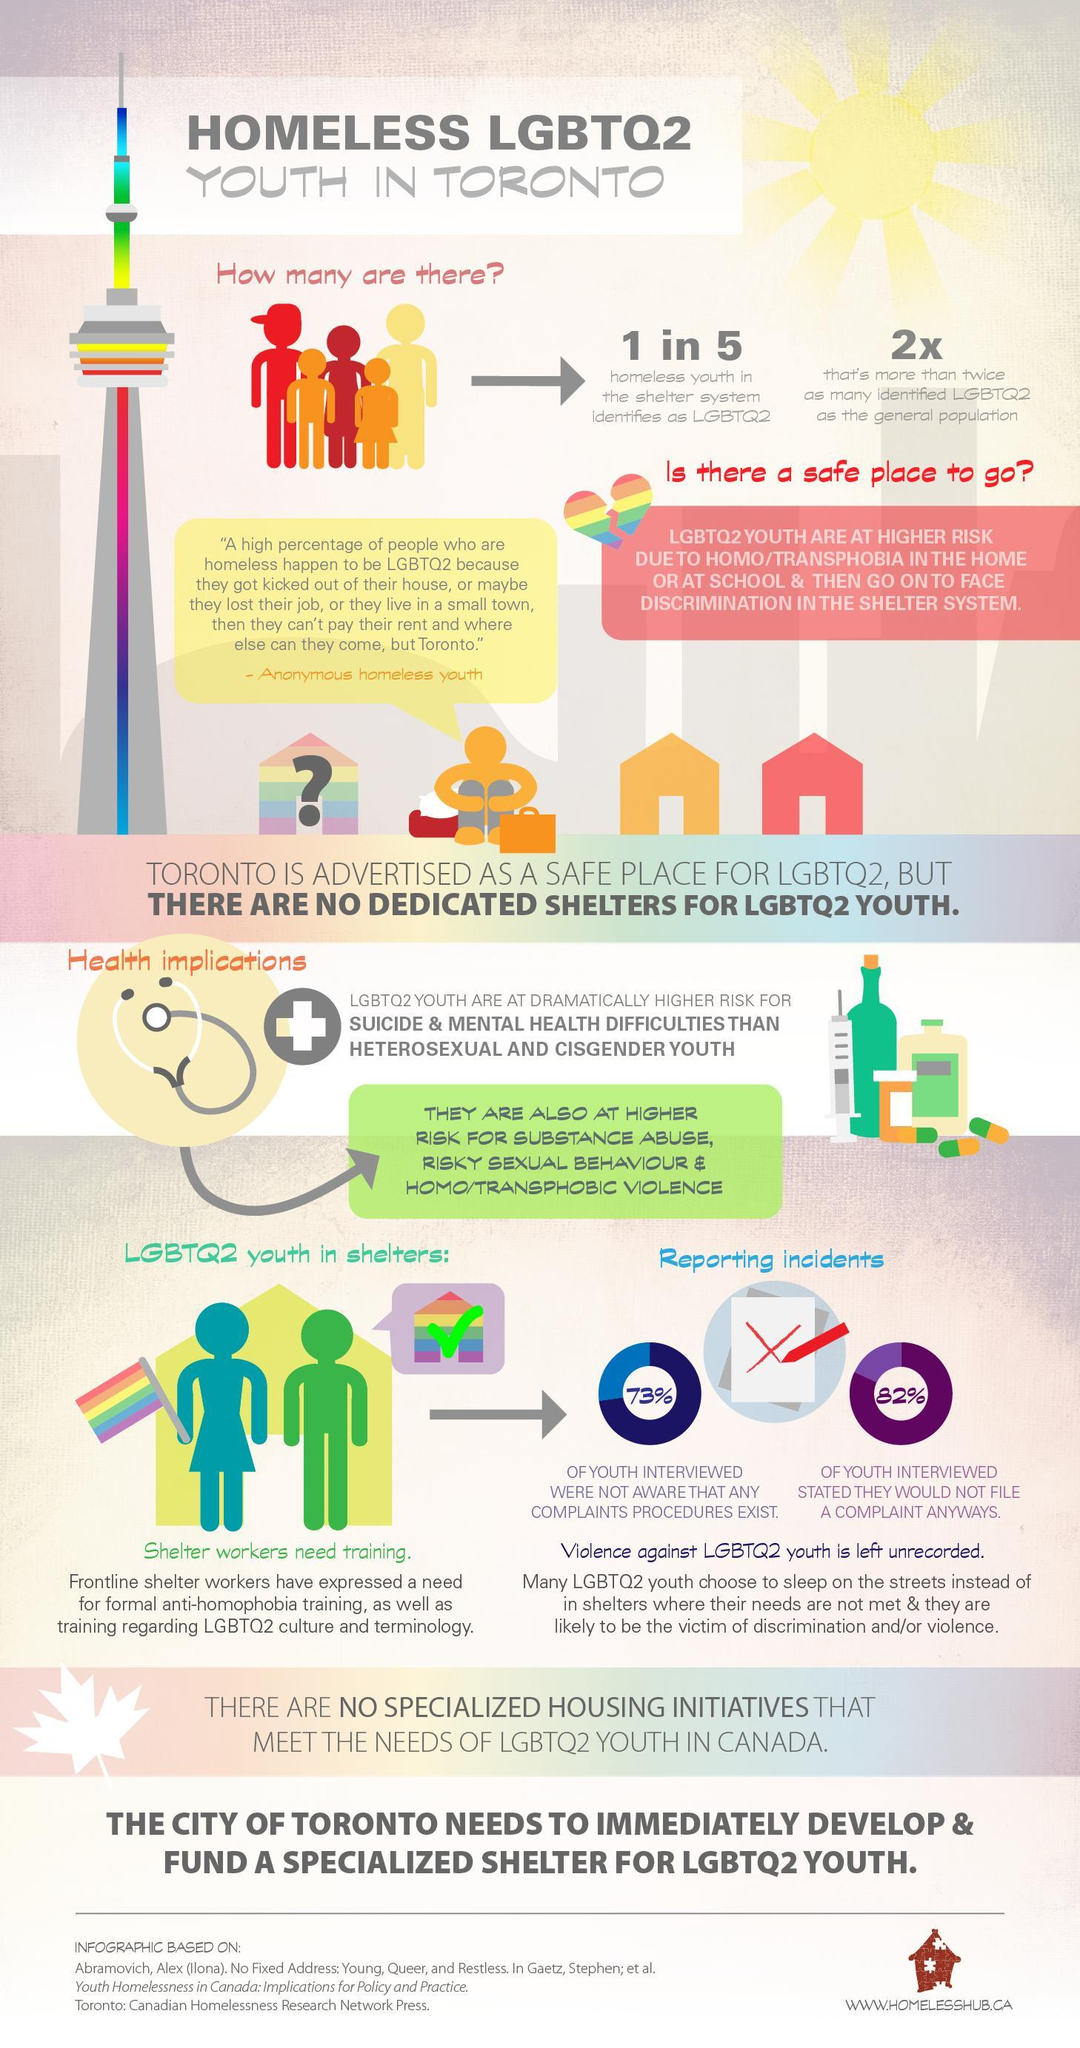What percent of youth in shelters are ready to file a complaint?
Answer the question with a short phrase. 18% 